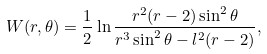Convert formula to latex. <formula><loc_0><loc_0><loc_500><loc_500>W ( r , \theta ) = \frac { 1 } { 2 } \ln { \frac { r ^ { 2 } ( r - 2 ) \sin ^ { 2 } \theta } { r ^ { 3 } \sin ^ { 2 } \theta - l ^ { 2 } ( r - 2 ) } } ,</formula> 